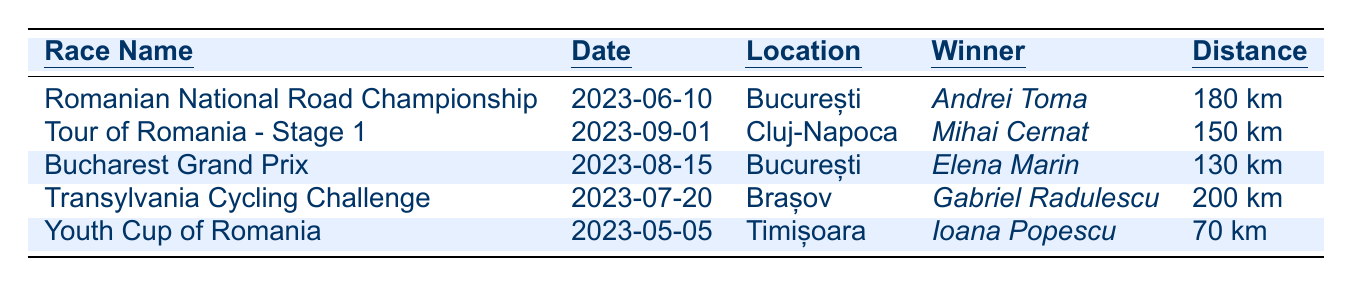What is the location of the Romanian National Road Championship? The table lists the location of the Romanian National Road Championship as București.
Answer: București Who won the Bucharest Grand Prix? According to the table, the winner of the Bucharest Grand Prix is Elena Marin.
Answer: Elena Marin What was the distance of the Youth Cup of Romania? The Youth Cup of Romania had a distance listed in the table as 70 km.
Answer: 70 km Which race had the longest distance and what was that distance? By comparing the distances in the table, the Transylvania Cycling Challenge had the longest distance at 200 km.
Answer: 200 km Did any race take place in July 2023? Yes, according to the table, the Transylvania Cycling Challenge took place on July 20, 2023.
Answer: Yes What was the combined distance of the Romanian National Road Championship and the Bucharest Grand Prix? The distance of the Romanian National Road Championship is 180 km and the distance of the Bucharest Grand Prix is 130 km. Adding these together gives 180 + 130 = 310 km.
Answer: 310 km Who finished the Tour of Romania - Stage 1, and how long did it take? The table shows that Mihai Cernat won the Tour of Romania - Stage 1 with a time of 4h 12m 34s.
Answer: Mihai Cernat, 4h 12m 34s Which category did the Transylvania Cycling Challenge fall under? The table indicates that the Transylvania Cycling Challenge falls under the Mountain category.
Answer: Mountain What was the winning time of the Youth Cup of Romania? The winning time for the Youth Cup of Romania, according to the table, is 1h 40m 20s.
Answer: 1h 40m 20s Which race took place last in the list and what was its date? The last race in the list is the Tour of Romania - Stage 1, which took place on 2023-09-01.
Answer: Tour of Romania - Stage 1, 2023-09-01 